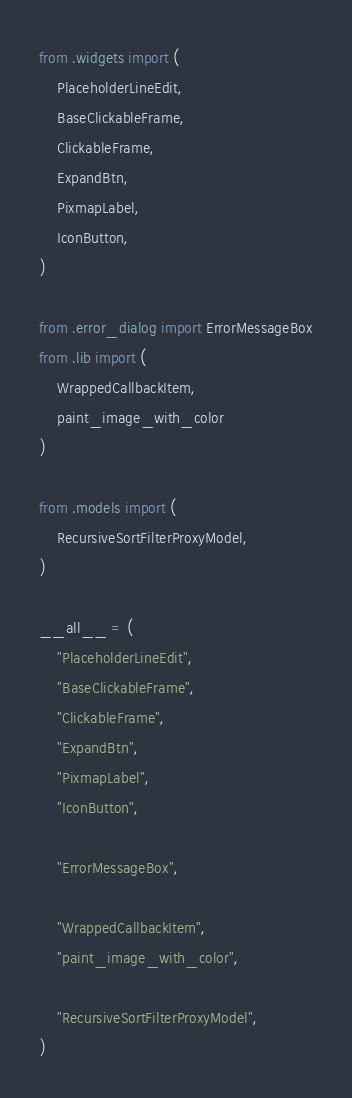Convert code to text. <code><loc_0><loc_0><loc_500><loc_500><_Python_>from .widgets import (
    PlaceholderLineEdit,
    BaseClickableFrame,
    ClickableFrame,
    ExpandBtn,
    PixmapLabel,
    IconButton,
)

from .error_dialog import ErrorMessageBox
from .lib import (
    WrappedCallbackItem,
    paint_image_with_color
)

from .models import (
    RecursiveSortFilterProxyModel,
)

__all__ = (
    "PlaceholderLineEdit",
    "BaseClickableFrame",
    "ClickableFrame",
    "ExpandBtn",
    "PixmapLabel",
    "IconButton",

    "ErrorMessageBox",

    "WrappedCallbackItem",
    "paint_image_with_color",

    "RecursiveSortFilterProxyModel",
)
</code> 